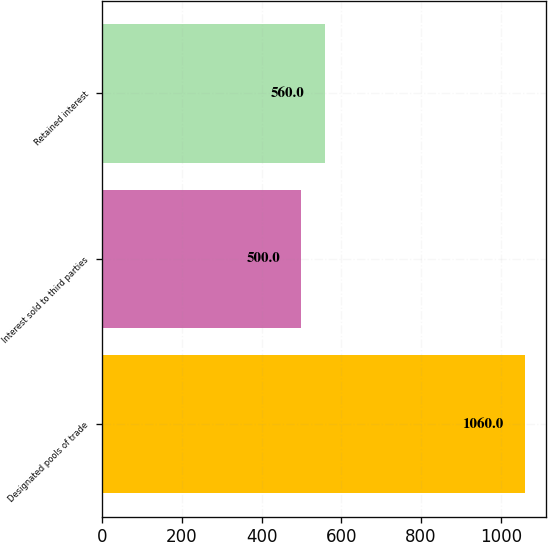Convert chart to OTSL. <chart><loc_0><loc_0><loc_500><loc_500><bar_chart><fcel>Designated pools of trade<fcel>Interest sold to third parties<fcel>Retained interest<nl><fcel>1060<fcel>500<fcel>560<nl></chart> 